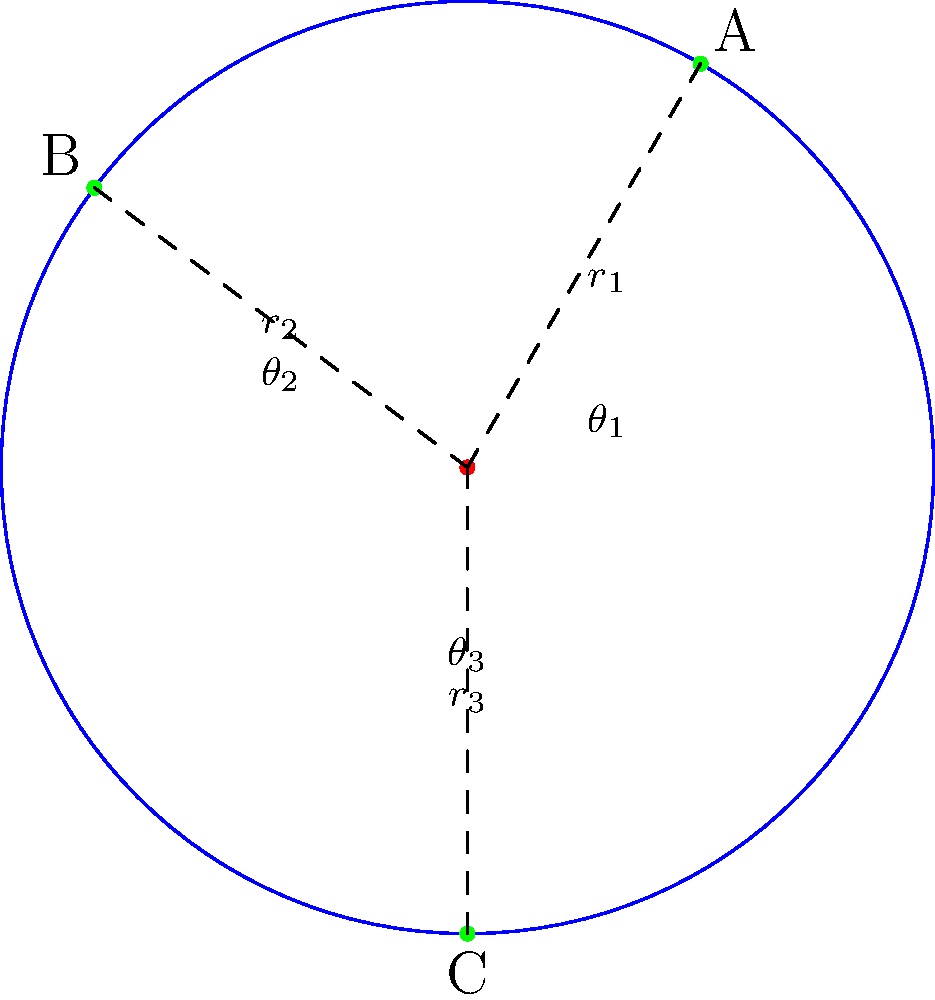As a logistics manager for a Mercedes transportation company, you're optimizing delivery routes in a circular city. The central warehouse is at the origin, and three delivery points (A, B, and C) are located at polar coordinates $(r_1, \theta_1)$, $(r_2, \theta_2)$, and $(r_3, \theta_3)$ respectively. If $r_1 = 3.5$ km, $r_2 = 5$ km, $r_3 = 5$ km, $\theta_1 = \frac{\pi}{4}$ rad, $\theta_2 = \frac{5\pi}{4}$ rad, and $\theta_3 = \frac{3\pi}{2}$ rad, what is the shortest total distance traveled to visit all three points and return to the warehouse? To find the shortest total distance, we'll use the following steps:

1) First, we need to calculate the distances between each pair of points. In a polar coordinate system, the distance between two points $(r_1, \theta_1)$ and $(r_2, \theta_2)$ is given by the formula:

   $$d = \sqrt{r_1^2 + r_2^2 - 2r_1r_2 \cos(\theta_2 - \theta_1)}$$

2) Let's calculate the distances:
   
   Warehouse to A: $d_{WA} = r_1 = 3.5$ km
   
   Warehouse to B: $d_{WB} = r_2 = 5$ km
   
   Warehouse to C: $d_{WC} = r_3 = 5$ km
   
   A to B: $d_{AB} = \sqrt{3.5^2 + 5^2 - 2(3.5)(5) \cos(\frac{5\pi}{4} - \frac{\pi}{4})} = \sqrt{36.25 + 35} = 8.54$ km
   
   B to C: $d_{BC} = \sqrt{5^2 + 5^2 - 2(5)(5) \cos(\frac{3\pi}{2} - \frac{5\pi}{4})} = \sqrt{50 - 50\cos(\frac{\pi}{4})} = 5.38$ km
   
   C to A: $d_{CA} = \sqrt{5^2 + 3.5^2 - 2(5)(3.5) \cos(\frac{\pi}{4} - \frac{3\pi}{2})} = \sqrt{36.25 + 35} = 8.54$ km

3) The possible routes are:
   W-A-B-C-W: $3.5 + 8.54 + 5.38 + 5 = 22.42$ km
   W-A-C-B-W: $3.5 + 8.54 + 5.38 + 5 = 22.42$ km
   W-B-A-C-W: $5 + 8.54 + 8.54 + 5 = 27.08$ km
   W-B-C-A-W: $5 + 5.38 + 8.54 + 3.5 = 22.42$ km
   W-C-A-B-W: $5 + 8.54 + 8.54 + 5 = 27.08$ km
   W-C-B-A-W: $5 + 5.38 + 8.54 + 3.5 = 22.42$ km

4) The shortest total distance is 22.42 km, which can be achieved through multiple routes.
Answer: 22.42 km 